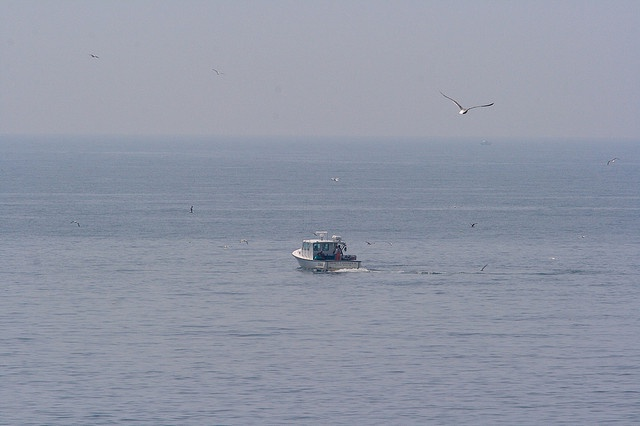Describe the objects in this image and their specific colors. I can see boat in darkgray, gray, and navy tones, bird in darkgray, gray, lightgray, and black tones, people in darkgray, purple, black, and gray tones, bird in darkgray and gray tones, and bird in darkgray and gray tones in this image. 